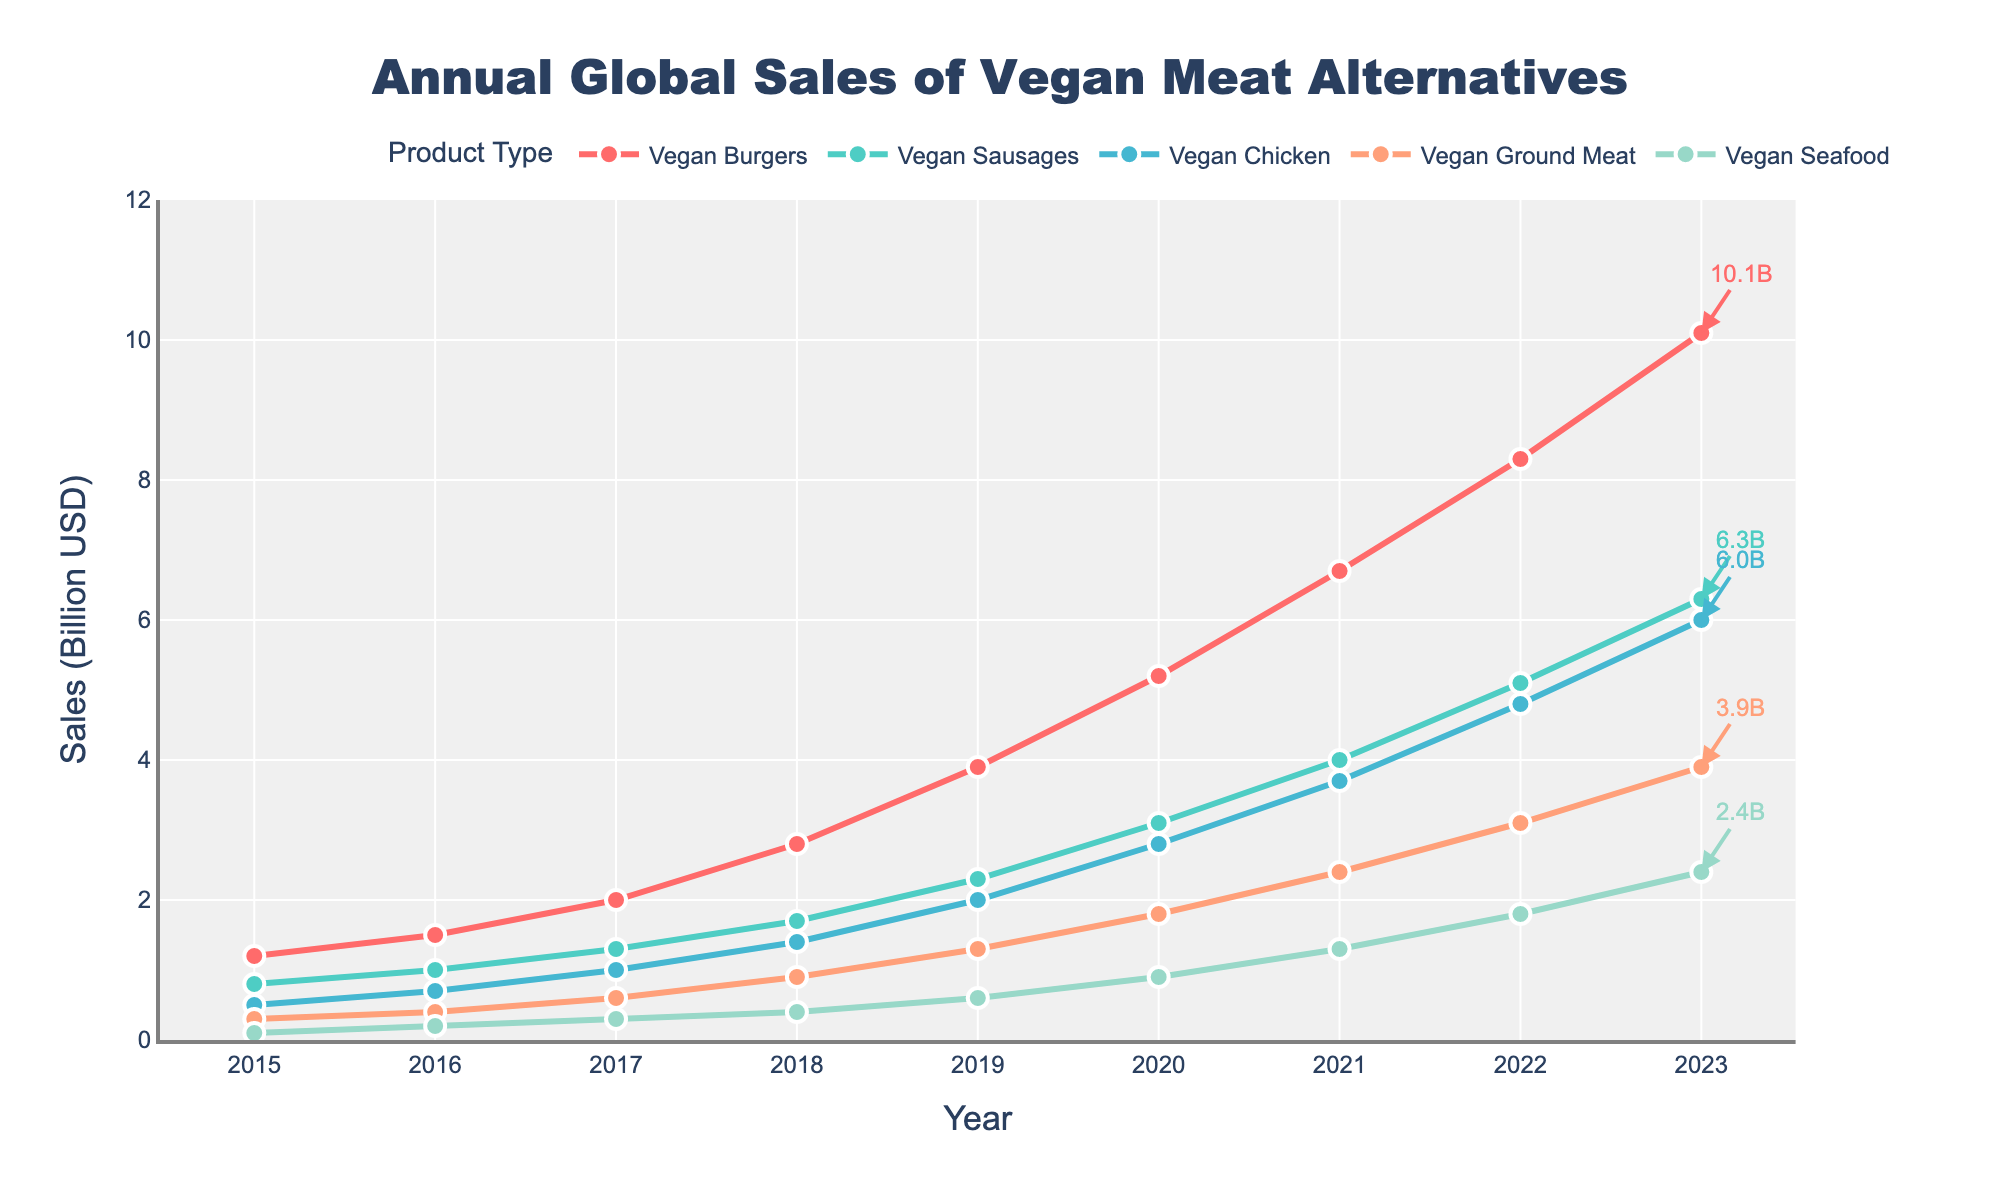What is the total sales of Vegan Burgers in 2020 and 2021? Sum the sales of Vegan Burgers for the years 2020 (5.2 billion USD) and 2021 (6.7 billion USD). The total is 5.2 + 6.7 = 11.9 billion USD.
Answer: 11.9 billion USD Which product type experienced the highest growth in sales from 2015 to 2023? Compare the sales of each product type in 2015 and 2023. Vegan Burgers grew from 1.2 to 10.1, Vegan Sausages from 0.8 to 6.3, Vegan Chicken from 0.5 to 6.0, Vegan Ground Meat from 0.3 to 3.9, and Vegan Seafood from 0.1 to 2.4. The highest growth is seen in Vegan Burgers.
Answer: Vegan Burgers In which year did Vegan Chicken sales first surpass 1 billion USD? Check the sales figures for Vegan Chicken across the years. The sales first surpassed 1 billion USD in 2017 (1.0 billion USD).
Answer: 2017 By how much did the sales of Vegan Seafood increase from 2015 to 2023? Subtract the sales of Vegan Seafood in 2015 (0.1 billion USD) from the sales in 2023 (2.4 billion USD). The increase is 2.4 - 0.1 = 2.3 billion USD.
Answer: 2.3 billion USD Which product type has the smallest sales in 2023? Compare the sales figures for all product types in 2023. Vegan Seafood has the smallest sales at 2.4 billion USD.
Answer: Vegan Seafood What is the combined sales of Vegan Ground Meat and Vegan Chicken in 2022? Add the sales of Vegan Ground Meat (3.1 billion USD) and Vegan Chicken (4.8 billion USD) in 2022. The combined sales are 3.1 + 4.8 = 7.9 billion USD.
Answer: 7.9 billion USD Between Vegan Sausages and Vegan Chicken, which had higher sales in 2019? Compare the sales of Vegan Sausages (2.3 billion USD) and Vegan Chicken (2.0 billion USD) in 2019. Vegan Sausages had higher sales.
Answer: Vegan Sausages What is the difference in sales between Vegan Burgers and Vegan Ground Meat in 2023? Subtract the sales of Vegan Ground Meat (3.9 billion USD) from the sales of Vegan Burgers (10.1 billion USD) in 2023. The difference is 10.1 - 3.9 = 6.2 billion USD.
Answer: 6.2 billion USD During which year did Vegan Ground Meat sales see the largest year-over-year increase? Analyze the year-over-year increase for Vegan Ground Meat. The largest increase is from 2022 (3.1 billion USD) to 2023 (3.9 billion USD), which is 3.9 - 3.1 = 0.8 billion USD.
Answer: 2023 What is the average annual sales of Vegan Seafood from 2015 to 2023? Sum the yearly sales of Vegan Seafood from 2015 to 2023 (0.1 + 0.2 + 0.3 + 0.4 + 0.6 + 0.9 + 1.3 + 1.8 + 2.4) and divide by the number of years (9). The average is (0.1 + 0.2 + 0.3 + 0.4 + 0.6 + 0.9 + 1.3 + 1.8 + 2.4) / 9 ≈ 0.89 billion USD.
Answer: 0.89 billion USD 